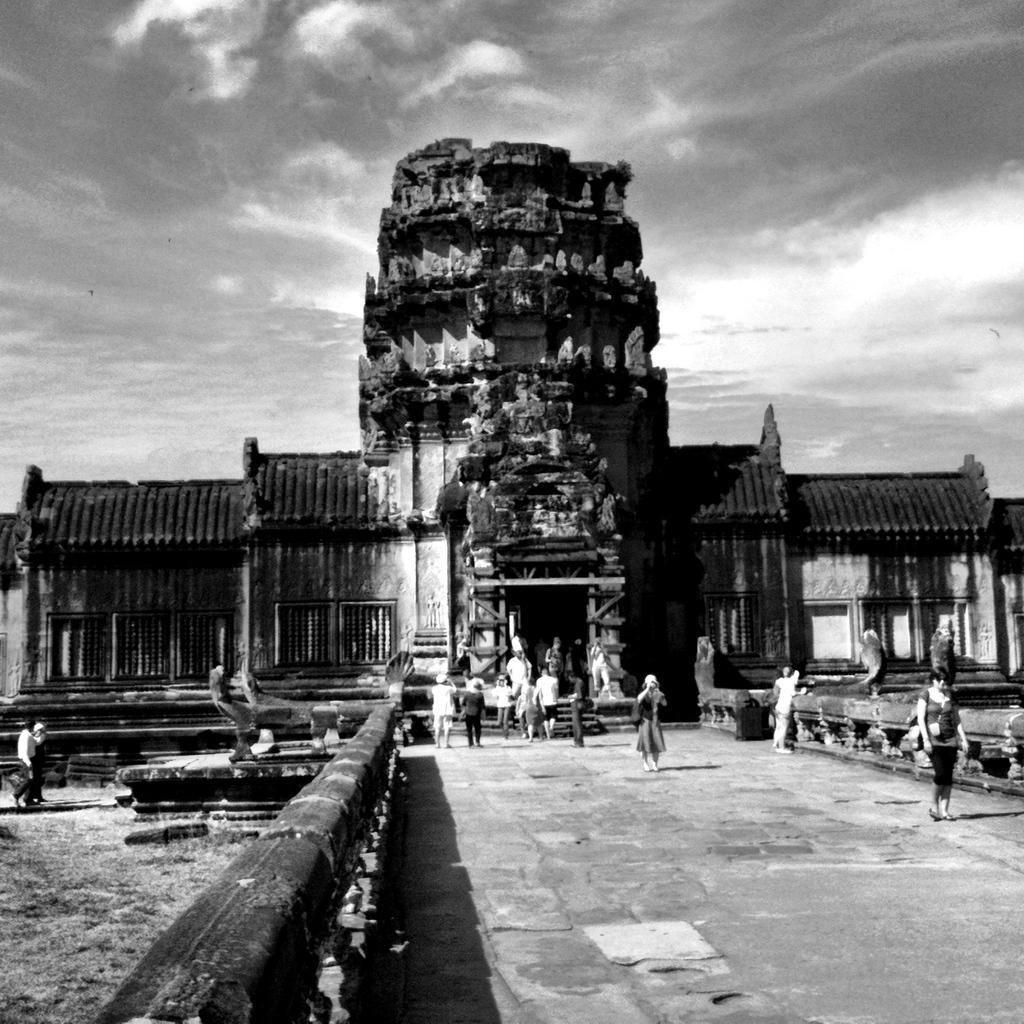Can you describe this image briefly? This image is a black and white image. This image is taken outdoors. At the top of the image there is a sky with clouds. At the bottom of the image there is a floor and there is a ground with grass on it. In the middle of the image there is an ancient architecture with walls, windows, doors, roofs, carvings and sculptures. A few people are walking on the floor and a few are standing. On the left side of the image a man and a woman are walking on the ground. 